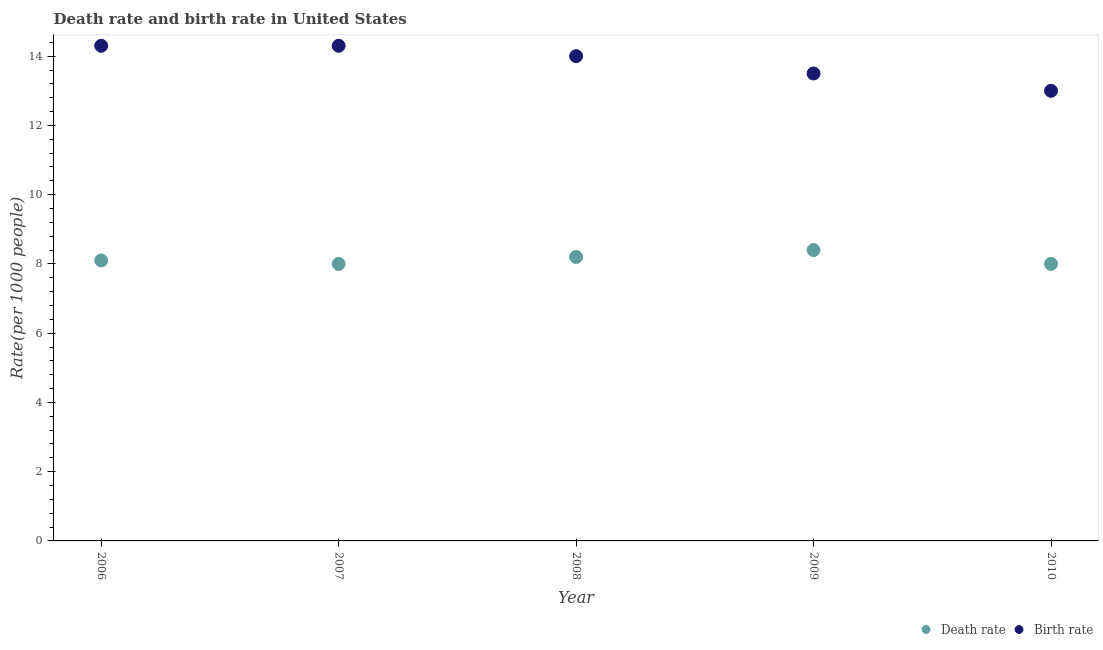Is the number of dotlines equal to the number of legend labels?
Offer a terse response. Yes. Across all years, what is the maximum birth rate?
Give a very brief answer. 14.3. Across all years, what is the minimum birth rate?
Keep it short and to the point. 13. What is the total birth rate in the graph?
Offer a terse response. 69.1. What is the difference between the death rate in 2006 and that in 2007?
Your response must be concise. 0.1. What is the average death rate per year?
Your response must be concise. 8.14. In the year 2006, what is the difference between the death rate and birth rate?
Make the answer very short. -6.2. In how many years, is the death rate greater than 8.8?
Your response must be concise. 0. What is the ratio of the death rate in 2007 to that in 2009?
Ensure brevity in your answer.  0.95. Is the birth rate in 2008 less than that in 2010?
Provide a succinct answer. No. Is the difference between the birth rate in 2007 and 2010 greater than the difference between the death rate in 2007 and 2010?
Ensure brevity in your answer.  Yes. What is the difference between the highest and the second highest death rate?
Your answer should be compact. 0.2. What is the difference between the highest and the lowest birth rate?
Keep it short and to the point. 1.3. In how many years, is the birth rate greater than the average birth rate taken over all years?
Ensure brevity in your answer.  3. Is the sum of the birth rate in 2009 and 2010 greater than the maximum death rate across all years?
Provide a succinct answer. Yes. Is the birth rate strictly less than the death rate over the years?
Your answer should be compact. No. Are the values on the major ticks of Y-axis written in scientific E-notation?
Provide a succinct answer. No. Where does the legend appear in the graph?
Ensure brevity in your answer.  Bottom right. How are the legend labels stacked?
Give a very brief answer. Horizontal. What is the title of the graph?
Make the answer very short. Death rate and birth rate in United States. Does "Birth rate" appear as one of the legend labels in the graph?
Provide a succinct answer. Yes. What is the label or title of the X-axis?
Offer a very short reply. Year. What is the label or title of the Y-axis?
Provide a succinct answer. Rate(per 1000 people). What is the Rate(per 1000 people) in Death rate in 2006?
Keep it short and to the point. 8.1. What is the Rate(per 1000 people) in Birth rate in 2006?
Your answer should be very brief. 14.3. What is the Rate(per 1000 people) of Death rate in 2008?
Your answer should be very brief. 8.2. What is the Rate(per 1000 people) of Birth rate in 2008?
Make the answer very short. 14. What is the Rate(per 1000 people) in Death rate in 2009?
Offer a terse response. 8.4. Across all years, what is the maximum Rate(per 1000 people) of Death rate?
Your answer should be compact. 8.4. Across all years, what is the maximum Rate(per 1000 people) in Birth rate?
Offer a very short reply. 14.3. Across all years, what is the minimum Rate(per 1000 people) in Birth rate?
Offer a terse response. 13. What is the total Rate(per 1000 people) in Death rate in the graph?
Offer a very short reply. 40.7. What is the total Rate(per 1000 people) in Birth rate in the graph?
Your answer should be very brief. 69.1. What is the difference between the Rate(per 1000 people) of Death rate in 2006 and that in 2008?
Offer a terse response. -0.1. What is the difference between the Rate(per 1000 people) in Birth rate in 2006 and that in 2008?
Provide a succinct answer. 0.3. What is the difference between the Rate(per 1000 people) in Death rate in 2006 and that in 2009?
Offer a very short reply. -0.3. What is the difference between the Rate(per 1000 people) in Death rate in 2006 and that in 2010?
Your response must be concise. 0.1. What is the difference between the Rate(per 1000 people) in Birth rate in 2006 and that in 2010?
Your answer should be very brief. 1.3. What is the difference between the Rate(per 1000 people) in Death rate in 2007 and that in 2008?
Ensure brevity in your answer.  -0.2. What is the difference between the Rate(per 1000 people) of Death rate in 2007 and that in 2009?
Offer a very short reply. -0.4. What is the difference between the Rate(per 1000 people) in Birth rate in 2007 and that in 2009?
Make the answer very short. 0.8. What is the difference between the Rate(per 1000 people) in Death rate in 2007 and that in 2010?
Offer a terse response. 0. What is the difference between the Rate(per 1000 people) of Birth rate in 2007 and that in 2010?
Offer a very short reply. 1.3. What is the difference between the Rate(per 1000 people) in Birth rate in 2008 and that in 2009?
Make the answer very short. 0.5. What is the difference between the Rate(per 1000 people) in Death rate in 2008 and that in 2010?
Ensure brevity in your answer.  0.2. What is the difference between the Rate(per 1000 people) of Death rate in 2009 and that in 2010?
Offer a terse response. 0.4. What is the difference between the Rate(per 1000 people) in Death rate in 2006 and the Rate(per 1000 people) in Birth rate in 2007?
Give a very brief answer. -6.2. What is the difference between the Rate(per 1000 people) of Death rate in 2006 and the Rate(per 1000 people) of Birth rate in 2009?
Offer a terse response. -5.4. What is the difference between the Rate(per 1000 people) of Death rate in 2006 and the Rate(per 1000 people) of Birth rate in 2010?
Your answer should be compact. -4.9. What is the difference between the Rate(per 1000 people) in Death rate in 2007 and the Rate(per 1000 people) in Birth rate in 2008?
Give a very brief answer. -6. What is the difference between the Rate(per 1000 people) in Death rate in 2007 and the Rate(per 1000 people) in Birth rate in 2010?
Make the answer very short. -5. What is the difference between the Rate(per 1000 people) in Death rate in 2008 and the Rate(per 1000 people) in Birth rate in 2009?
Provide a succinct answer. -5.3. What is the difference between the Rate(per 1000 people) of Death rate in 2009 and the Rate(per 1000 people) of Birth rate in 2010?
Give a very brief answer. -4.6. What is the average Rate(per 1000 people) in Death rate per year?
Provide a succinct answer. 8.14. What is the average Rate(per 1000 people) of Birth rate per year?
Provide a succinct answer. 13.82. In the year 2008, what is the difference between the Rate(per 1000 people) in Death rate and Rate(per 1000 people) in Birth rate?
Your response must be concise. -5.8. In the year 2009, what is the difference between the Rate(per 1000 people) of Death rate and Rate(per 1000 people) of Birth rate?
Ensure brevity in your answer.  -5.1. What is the ratio of the Rate(per 1000 people) of Death rate in 2006 to that in 2007?
Offer a terse response. 1.01. What is the ratio of the Rate(per 1000 people) in Death rate in 2006 to that in 2008?
Your answer should be compact. 0.99. What is the ratio of the Rate(per 1000 people) in Birth rate in 2006 to that in 2008?
Give a very brief answer. 1.02. What is the ratio of the Rate(per 1000 people) in Birth rate in 2006 to that in 2009?
Keep it short and to the point. 1.06. What is the ratio of the Rate(per 1000 people) in Death rate in 2006 to that in 2010?
Ensure brevity in your answer.  1.01. What is the ratio of the Rate(per 1000 people) in Death rate in 2007 to that in 2008?
Offer a very short reply. 0.98. What is the ratio of the Rate(per 1000 people) in Birth rate in 2007 to that in 2008?
Make the answer very short. 1.02. What is the ratio of the Rate(per 1000 people) of Birth rate in 2007 to that in 2009?
Offer a terse response. 1.06. What is the ratio of the Rate(per 1000 people) of Death rate in 2008 to that in 2009?
Ensure brevity in your answer.  0.98. What is the ratio of the Rate(per 1000 people) of Death rate in 2008 to that in 2010?
Ensure brevity in your answer.  1.02. What is the ratio of the Rate(per 1000 people) of Birth rate in 2008 to that in 2010?
Your answer should be compact. 1.08. What is the ratio of the Rate(per 1000 people) in Birth rate in 2009 to that in 2010?
Ensure brevity in your answer.  1.04. What is the difference between the highest and the second highest Rate(per 1000 people) in Birth rate?
Ensure brevity in your answer.  0. What is the difference between the highest and the lowest Rate(per 1000 people) of Death rate?
Make the answer very short. 0.4. 